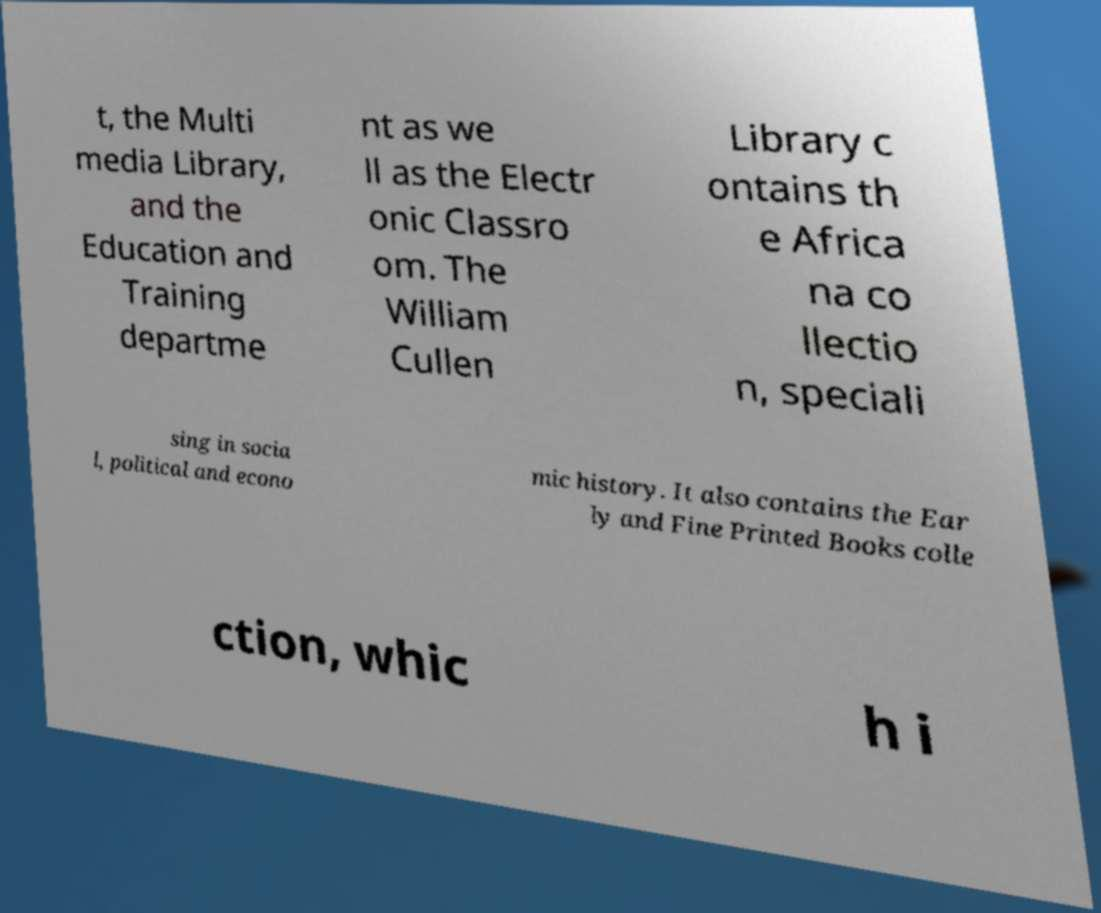Can you accurately transcribe the text from the provided image for me? t, the Multi media Library, and the Education and Training departme nt as we ll as the Electr onic Classro om. The William Cullen Library c ontains th e Africa na co llectio n, speciali sing in socia l, political and econo mic history. It also contains the Ear ly and Fine Printed Books colle ction, whic h i 